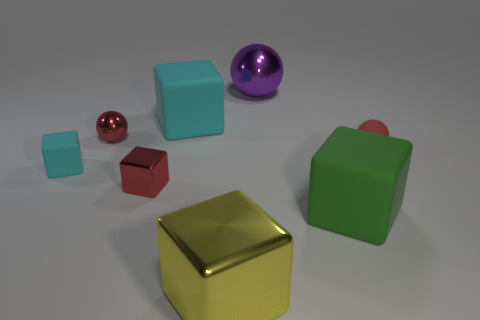There is a red metal object that is the same shape as the tiny red matte object; what is its size?
Offer a terse response. Small. Are there more red blocks right of the matte ball than rubber balls?
Ensure brevity in your answer.  No. Is the material of the tiny red sphere that is left of the rubber sphere the same as the yellow object?
Provide a succinct answer. Yes. There is a red sphere that is to the left of the large yellow block on the left side of the big shiny object that is behind the green rubber thing; how big is it?
Offer a very short reply. Small. There is a red ball that is made of the same material as the big green block; what size is it?
Ensure brevity in your answer.  Small. What color is the big cube that is on the left side of the green object and behind the yellow metallic block?
Provide a succinct answer. Cyan. Does the large metal thing that is to the left of the purple sphere have the same shape as the cyan matte thing that is to the left of the small red metal cube?
Offer a terse response. Yes. There is a object behind the large cyan object; what is its material?
Offer a very short reply. Metal. There is a shiny cube that is the same color as the tiny matte ball; what size is it?
Provide a short and direct response. Small. How many objects are either small spheres that are on the right side of the large green rubber thing or big green shiny balls?
Your response must be concise. 1. 